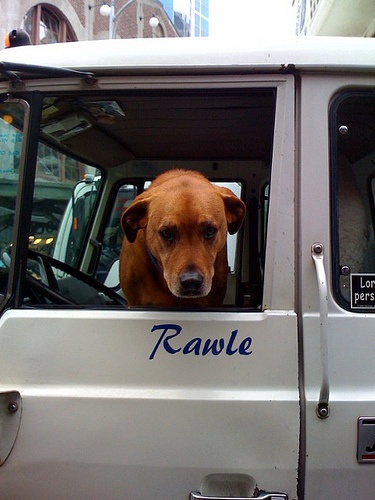Describe the objects in this image and their specific colors. I can see truck in black, darkgray, gray, lightgray, and white tones and dog in lightgray, black, maroon, brown, and tan tones in this image. 